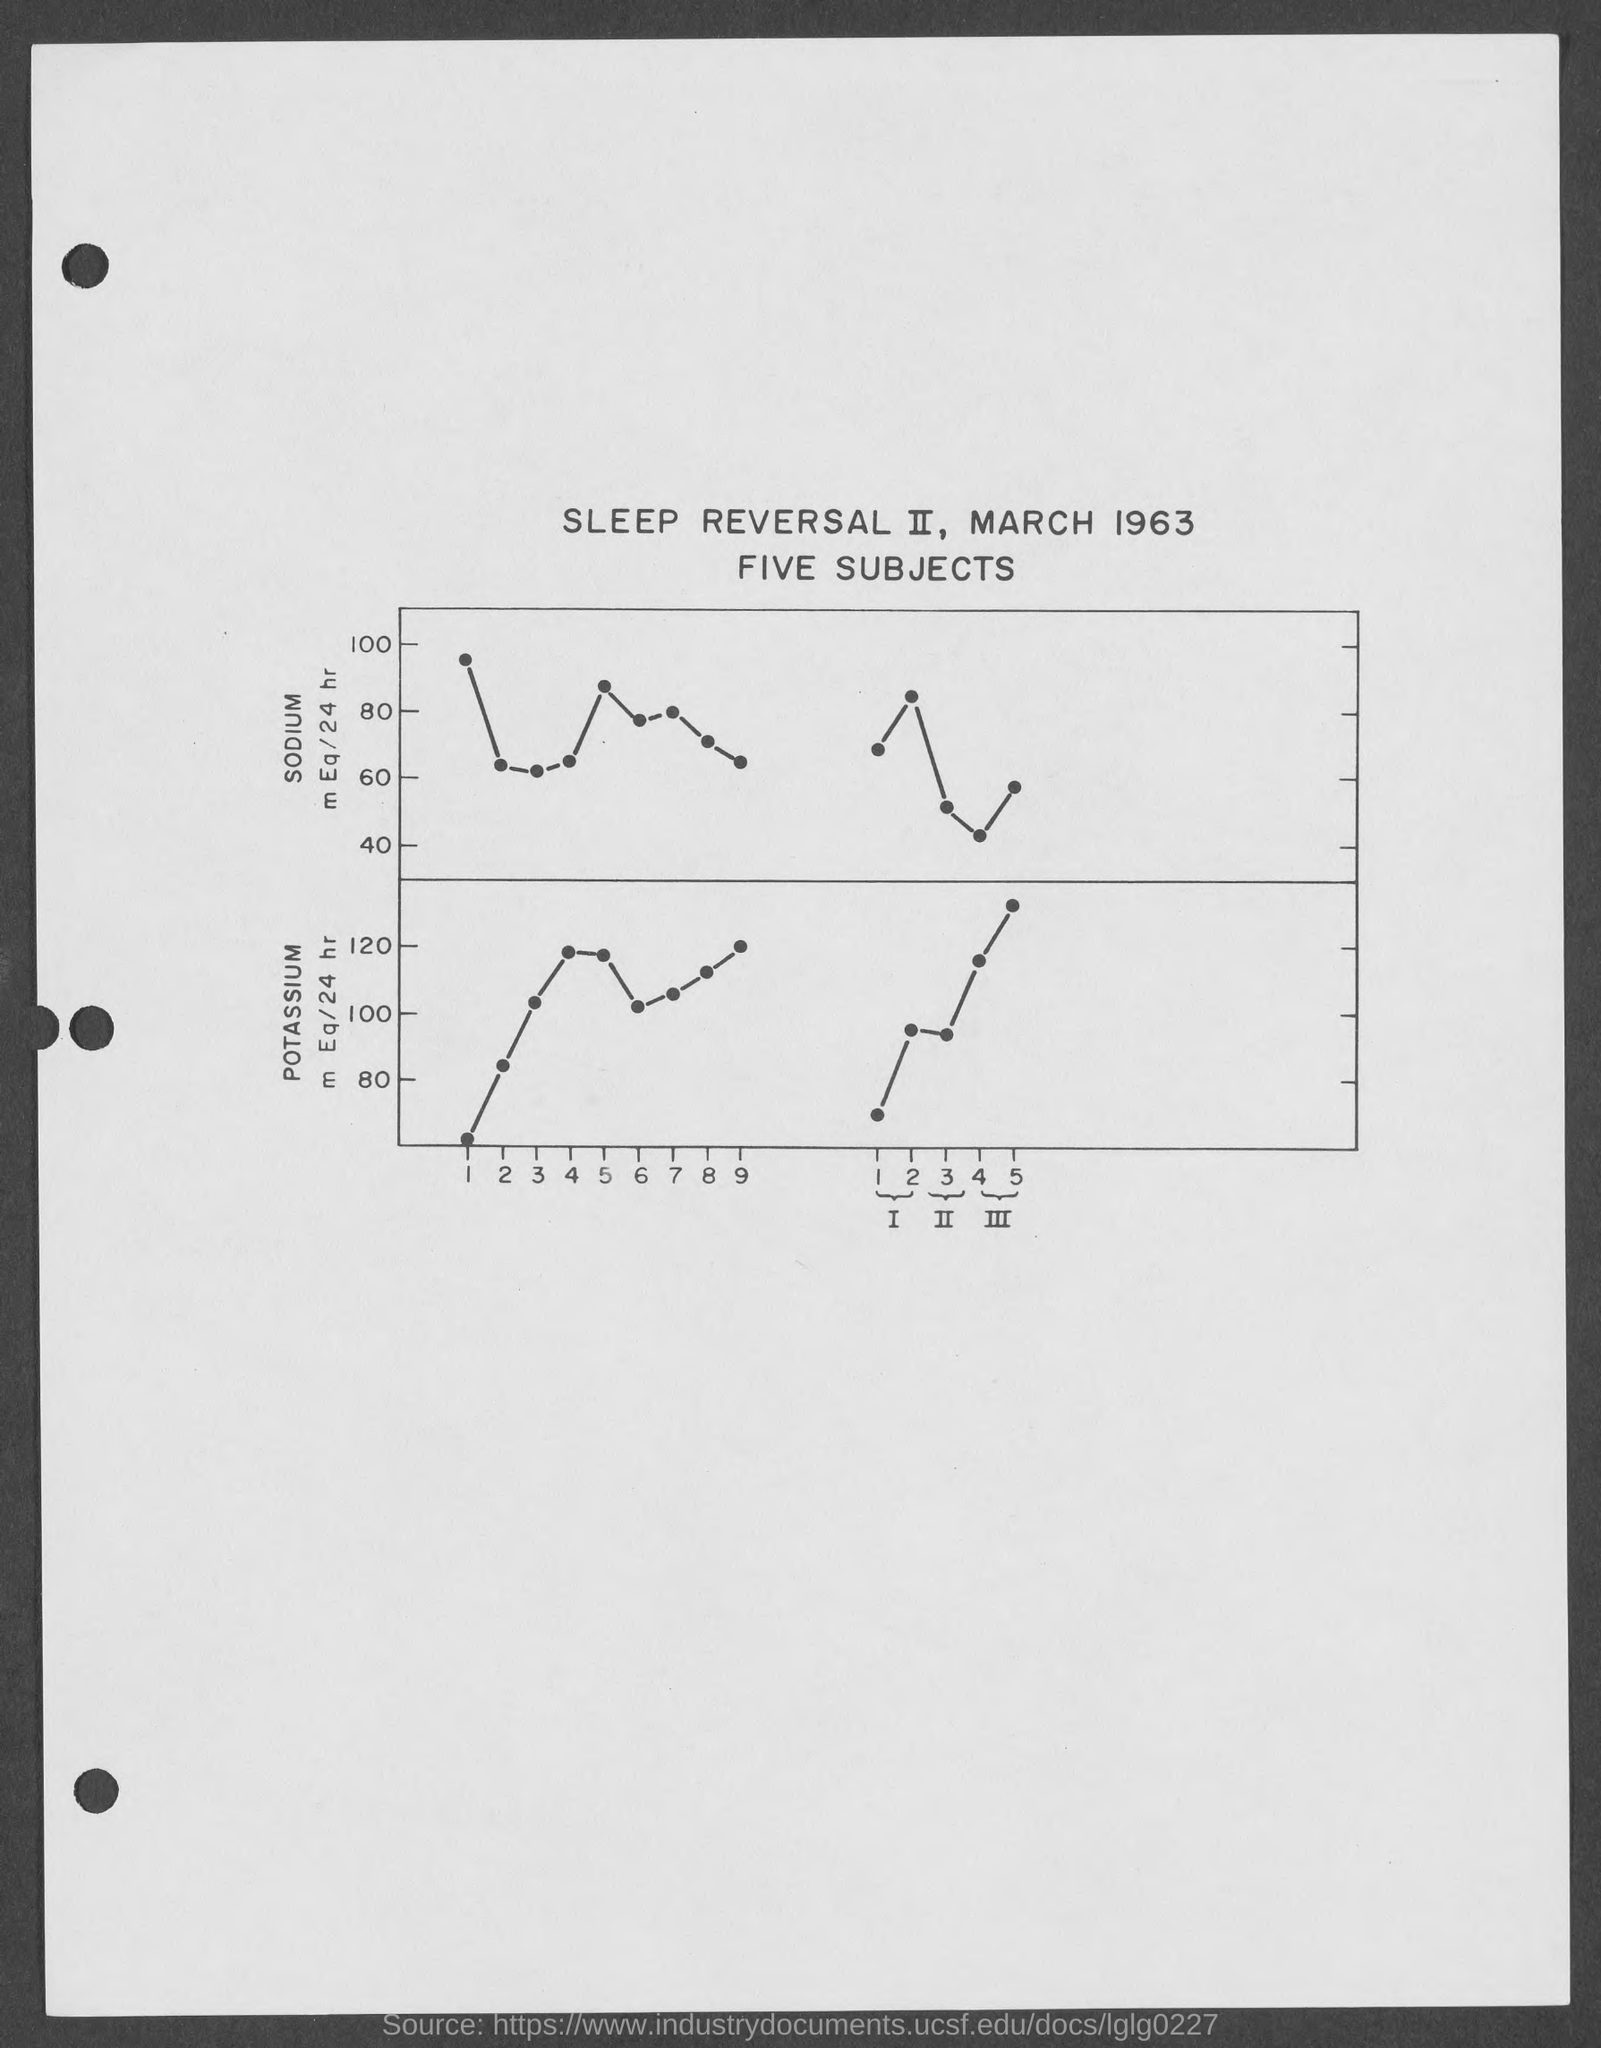Point out several critical features in this image. The title of the graph mentions the month of March. The element written on the Y-axis of the first graph is sodium. The name of the element written on the Y-axis of the second graph is potassium. The title of the graph contains a year, and the question asks for that year to be identified. 